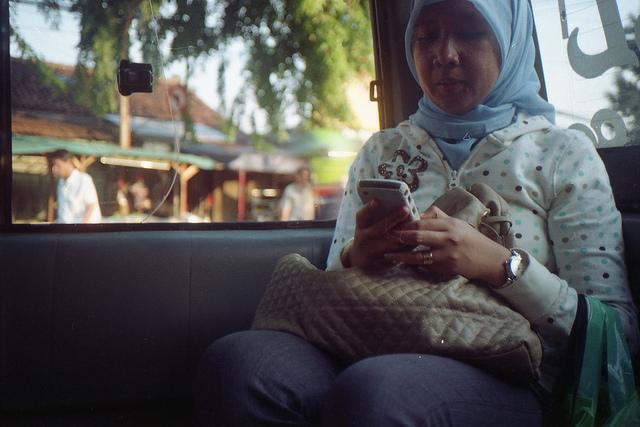What is one name for the type of headwear the woman is wearing? Please explain your reasoning. veil. The name is a veil. 